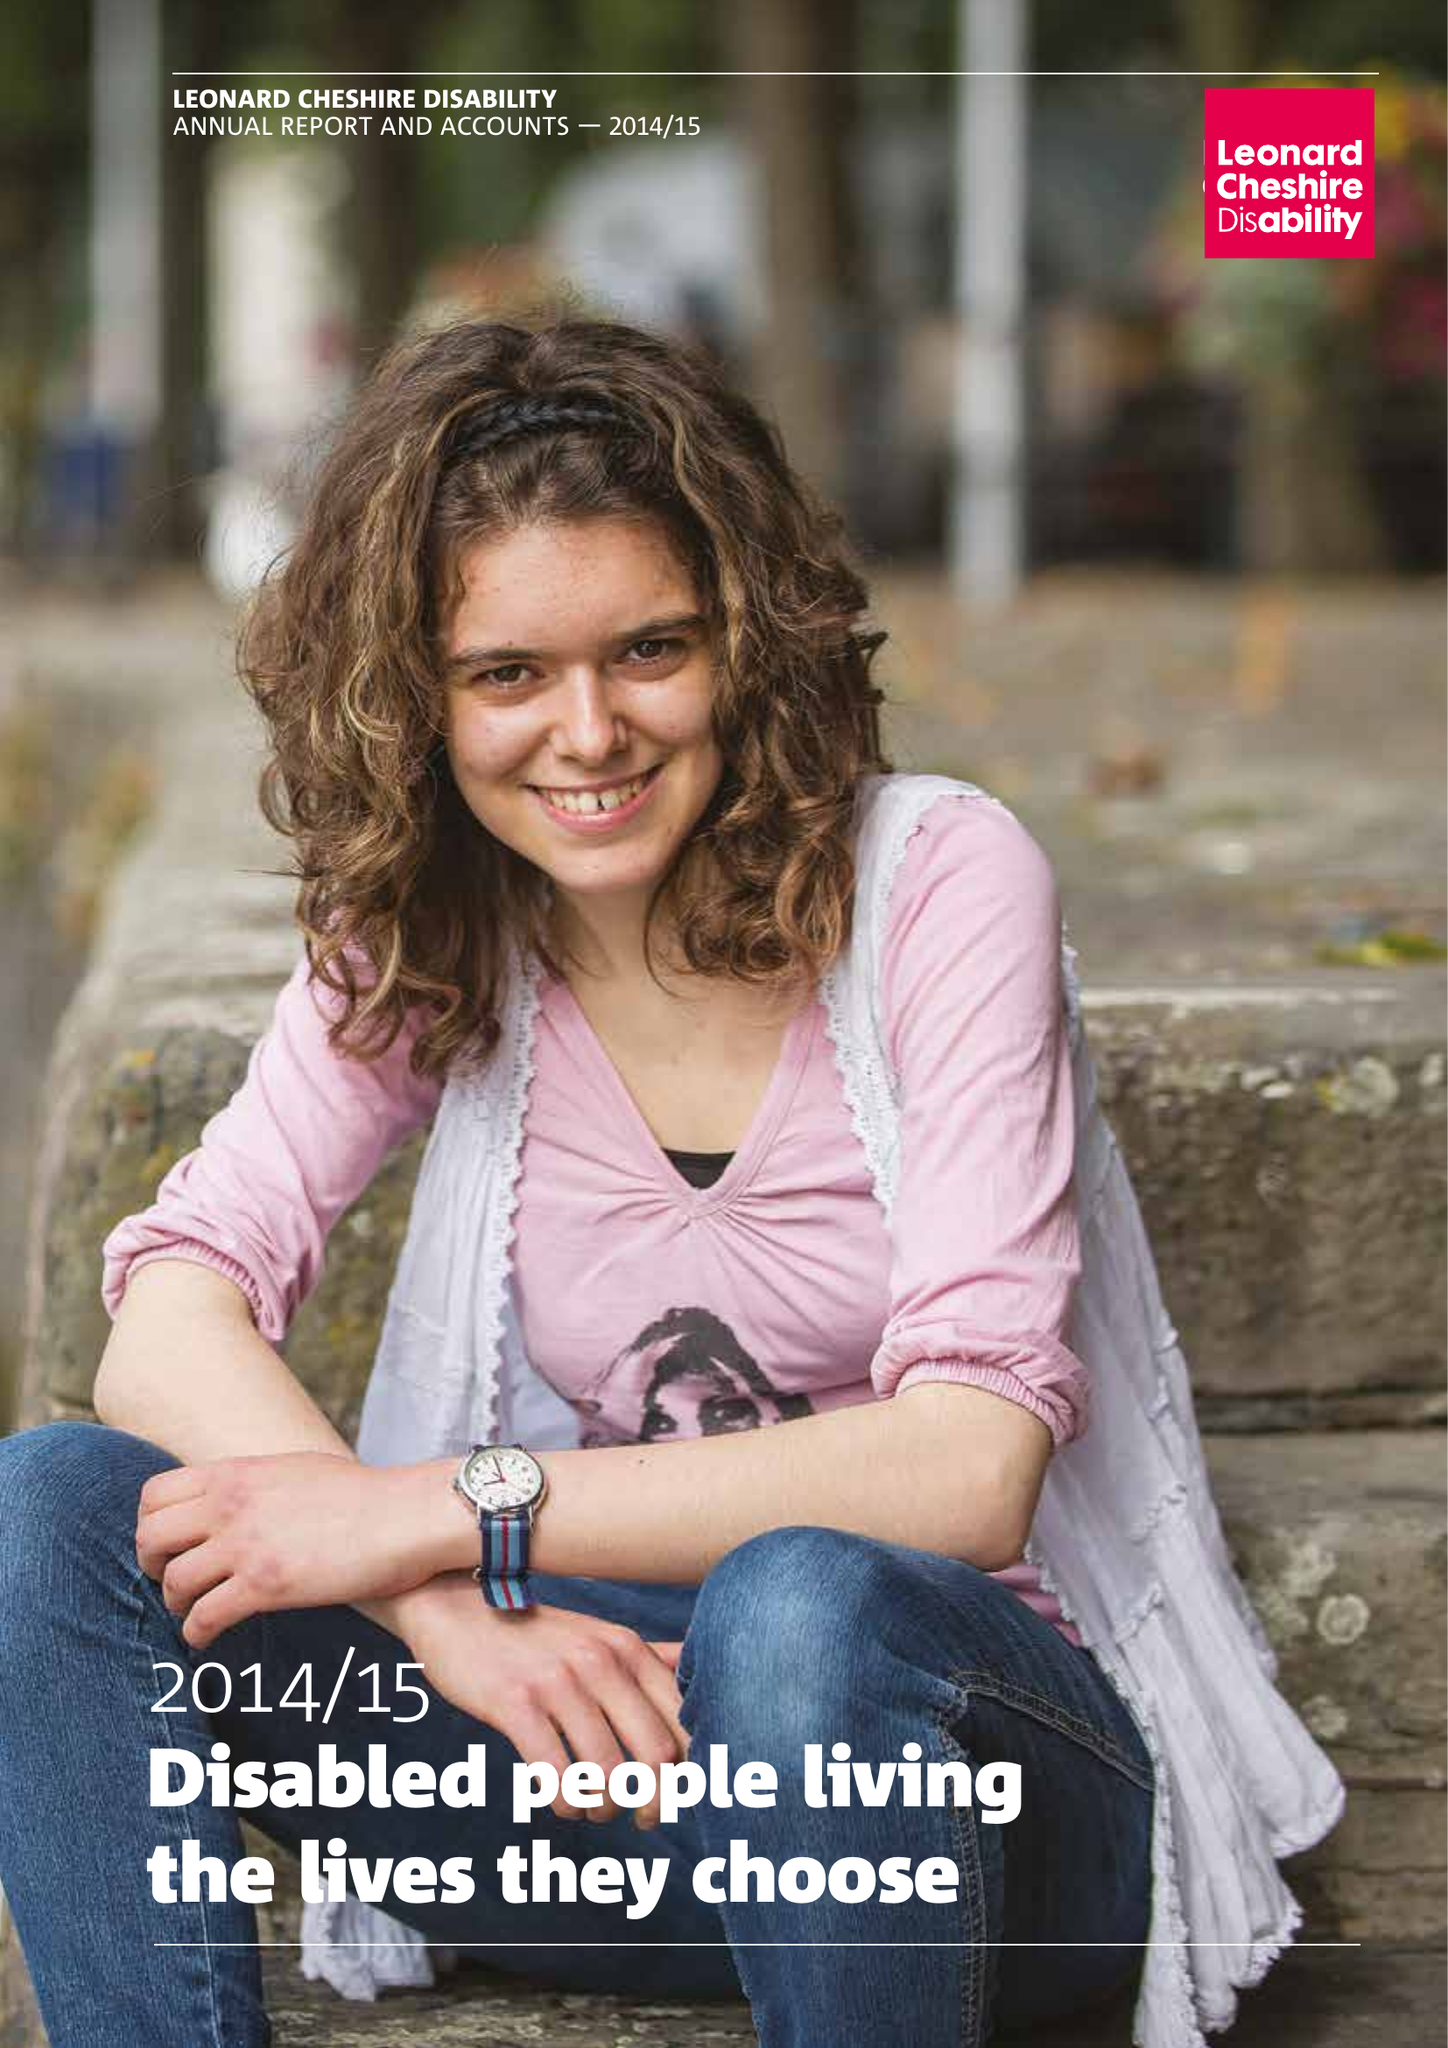What is the value for the income_annually_in_british_pounds?
Answer the question using a single word or phrase. 162241000.00 